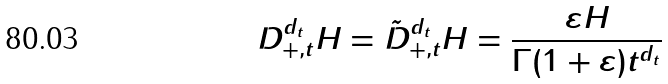<formula> <loc_0><loc_0><loc_500><loc_500>D _ { + , t } ^ { d _ { t } } H = \tilde { D } _ { + , t } ^ { d _ { t } } H = \frac { \varepsilon H } { \Gamma ( 1 + \varepsilon ) t ^ { d _ { t } } }</formula> 